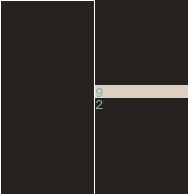<code> <loc_0><loc_0><loc_500><loc_500><_SQL_>9
2</code> 